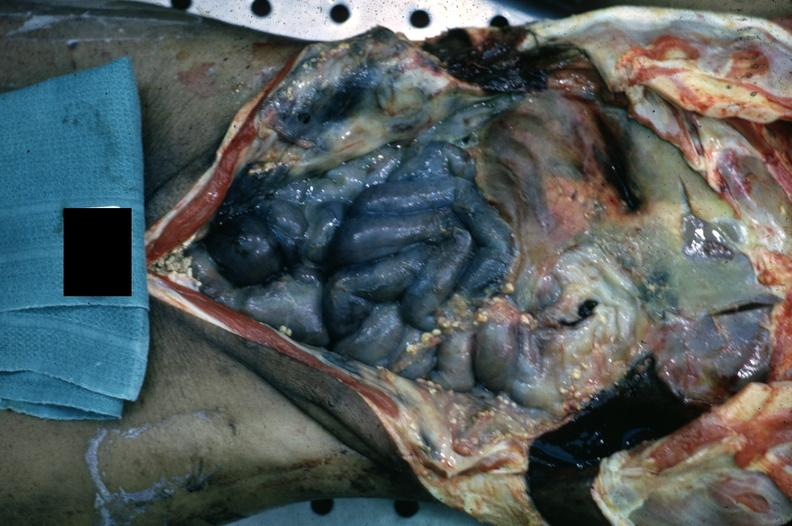where is this area in the body?
Answer the question using a single word or phrase. Abdomen 